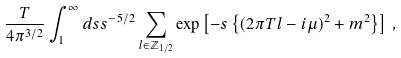Convert formula to latex. <formula><loc_0><loc_0><loc_500><loc_500>\frac { T } { 4 \pi ^ { 3 / 2 } } \int _ { 1 } ^ { \infty } d s s ^ { - 5 / 2 } \sum _ { l \in \mathbb { Z } _ { 1 / 2 } } \exp \left [ - s \left \{ ( 2 \pi T l - i \mu ) ^ { 2 } + m ^ { 2 } \right \} \right ] \, ,</formula> 